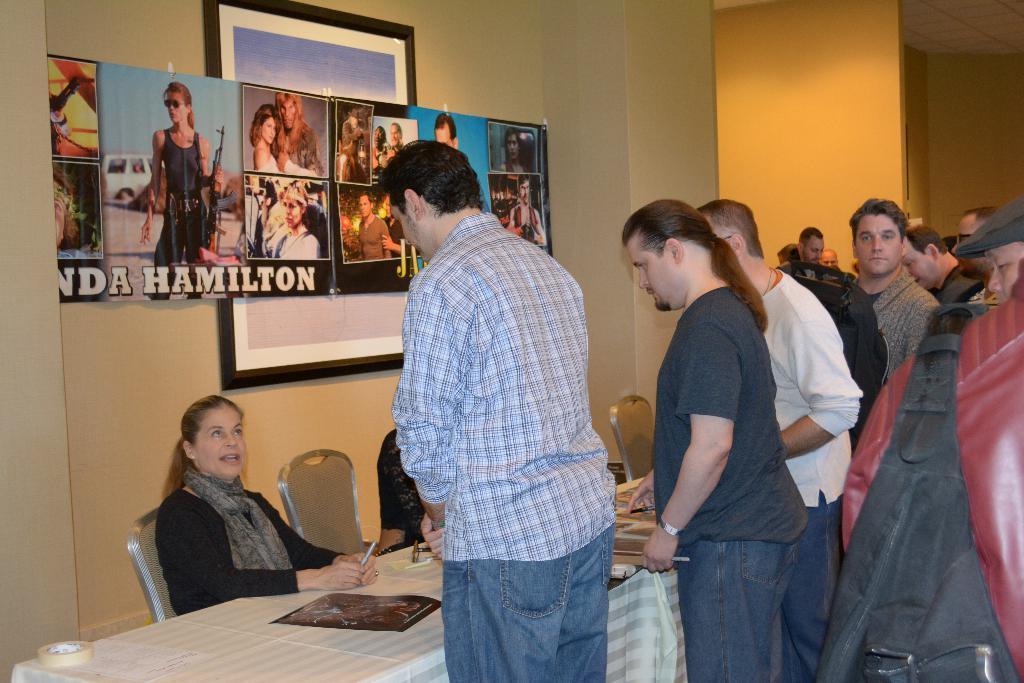How would you summarize this image in a sentence or two? In this image we can see people standing on the floor and there is a woman sitting on the chair. There is a table. On the table we can see cloth, paper, tape, and other objects. In the background we can see walls, pillar, posters, frame, and ceiling. 